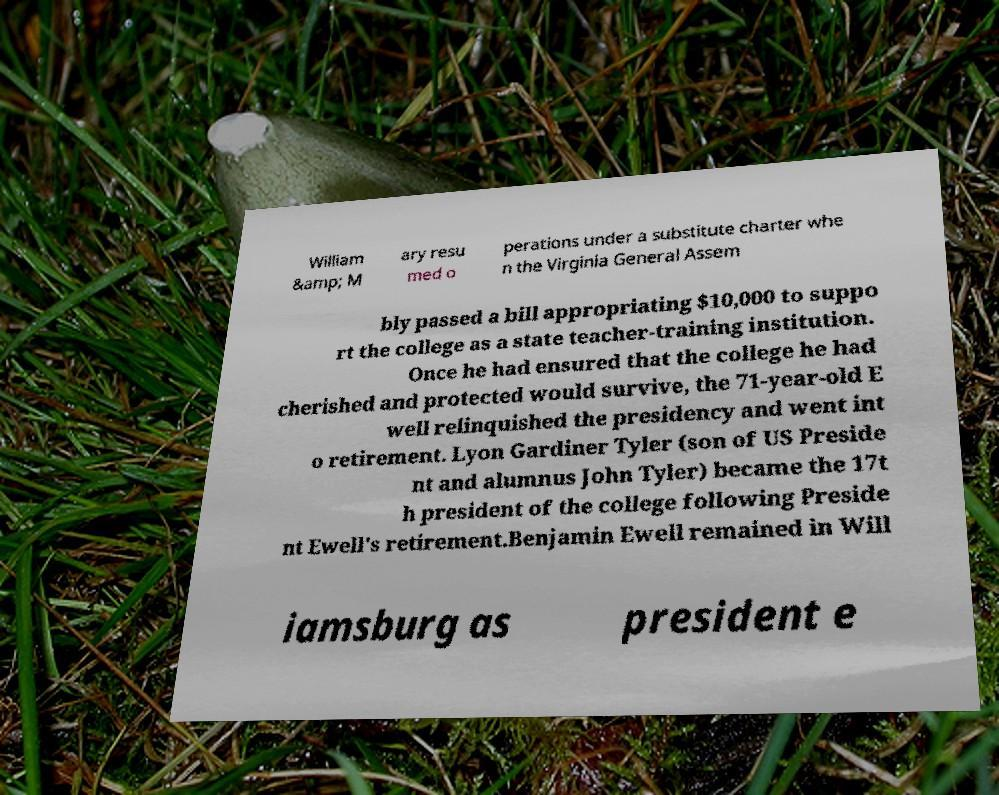For documentation purposes, I need the text within this image transcribed. Could you provide that? William &amp; M ary resu med o perations under a substitute charter whe n the Virginia General Assem bly passed a bill appropriating $10,000 to suppo rt the college as a state teacher-training institution. Once he had ensured that the college he had cherished and protected would survive, the 71-year-old E well relinquished the presidency and went int o retirement. Lyon Gardiner Tyler (son of US Preside nt and alumnus John Tyler) became the 17t h president of the college following Preside nt Ewell's retirement.Benjamin Ewell remained in Will iamsburg as president e 